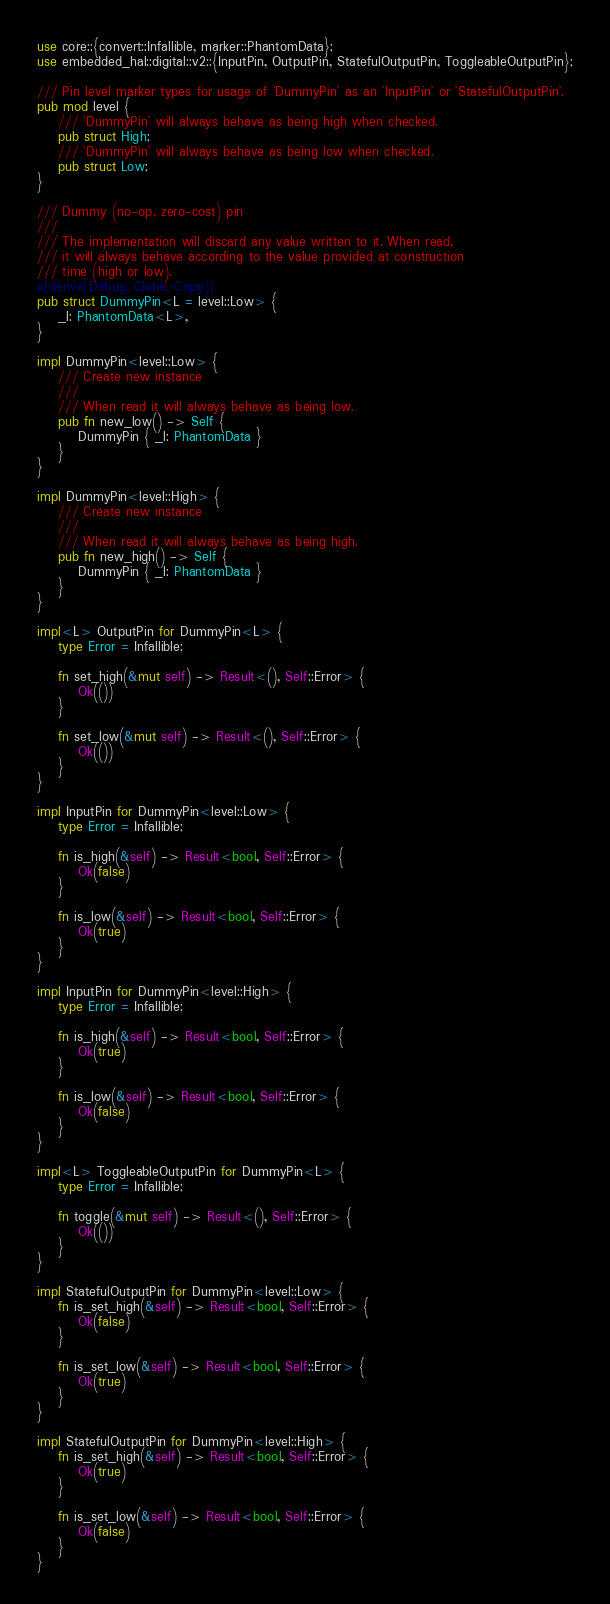Convert code to text. <code><loc_0><loc_0><loc_500><loc_500><_Rust_>use core::{convert::Infallible, marker::PhantomData};
use embedded_hal::digital::v2::{InputPin, OutputPin, StatefulOutputPin, ToggleableOutputPin};

/// Pin level marker types for usage of `DummyPin` as an `InputPin` or `StatefulOutputPin`.
pub mod level {
    /// `DummyPin` will always behave as being high when checked.
    pub struct High;
    /// `DummyPin` will always behave as being low when checked.
    pub struct Low;
}

/// Dummy (no-op, zero-cost) pin
///
/// The implementation will discard any value written to it. When read,
/// it will always behave according to the value provided at construction
/// time (high or low).
#[derive(Debug, Clone, Copy)]
pub struct DummyPin<L = level::Low> {
    _l: PhantomData<L>,
}

impl DummyPin<level::Low> {
    /// Create new instance
    ///
    /// When read it will always behave as being low.
    pub fn new_low() -> Self {
        DummyPin { _l: PhantomData }
    }
}

impl DummyPin<level::High> {
    /// Create new instance
    ///
    /// When read it will always behave as being high.
    pub fn new_high() -> Self {
        DummyPin { _l: PhantomData }
    }
}

impl<L> OutputPin for DummyPin<L> {
    type Error = Infallible;

    fn set_high(&mut self) -> Result<(), Self::Error> {
        Ok(())
    }

    fn set_low(&mut self) -> Result<(), Self::Error> {
        Ok(())
    }
}

impl InputPin for DummyPin<level::Low> {
    type Error = Infallible;

    fn is_high(&self) -> Result<bool, Self::Error> {
        Ok(false)
    }

    fn is_low(&self) -> Result<bool, Self::Error> {
        Ok(true)
    }
}

impl InputPin for DummyPin<level::High> {
    type Error = Infallible;

    fn is_high(&self) -> Result<bool, Self::Error> {
        Ok(true)
    }

    fn is_low(&self) -> Result<bool, Self::Error> {
        Ok(false)
    }
}

impl<L> ToggleableOutputPin for DummyPin<L> {
    type Error = Infallible;

    fn toggle(&mut self) -> Result<(), Self::Error> {
        Ok(())
    }
}

impl StatefulOutputPin for DummyPin<level::Low> {
    fn is_set_high(&self) -> Result<bool, Self::Error> {
        Ok(false)
    }

    fn is_set_low(&self) -> Result<bool, Self::Error> {
        Ok(true)
    }
}

impl StatefulOutputPin for DummyPin<level::High> {
    fn is_set_high(&self) -> Result<bool, Self::Error> {
        Ok(true)
    }

    fn is_set_low(&self) -> Result<bool, Self::Error> {
        Ok(false)
    }
}
</code> 